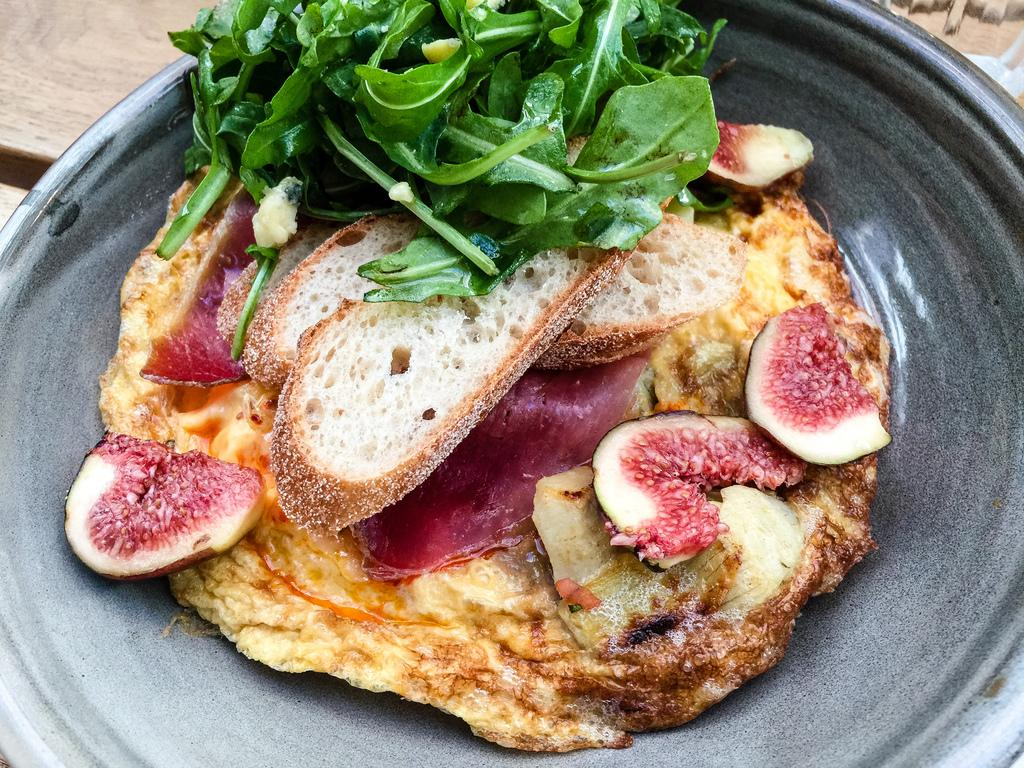What is on the table in the image? There is a bowl on a table in the image. What is inside the bowl? The bowl contains a lot of food. Who is the creator of the sweater seen in the image? There is no sweater present in the image. 